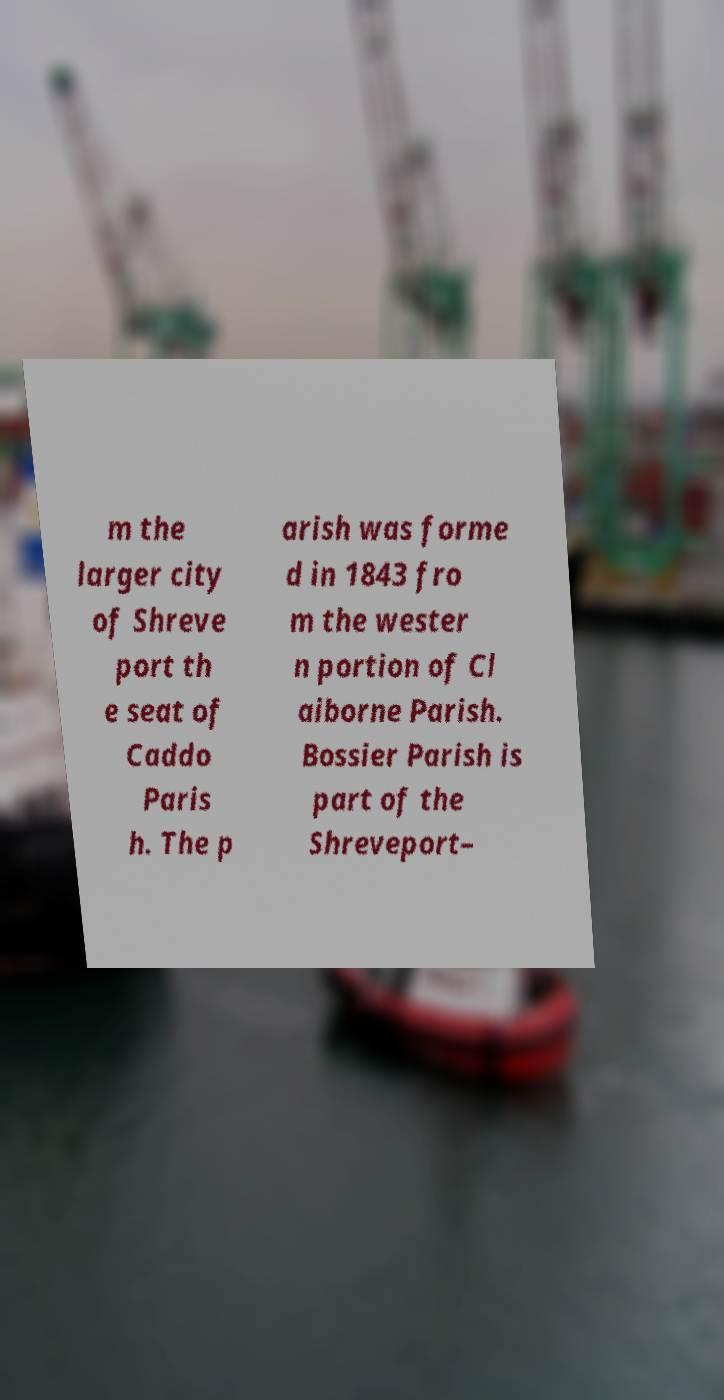Could you assist in decoding the text presented in this image and type it out clearly? m the larger city of Shreve port th e seat of Caddo Paris h. The p arish was forme d in 1843 fro m the wester n portion of Cl aiborne Parish. Bossier Parish is part of the Shreveport– 